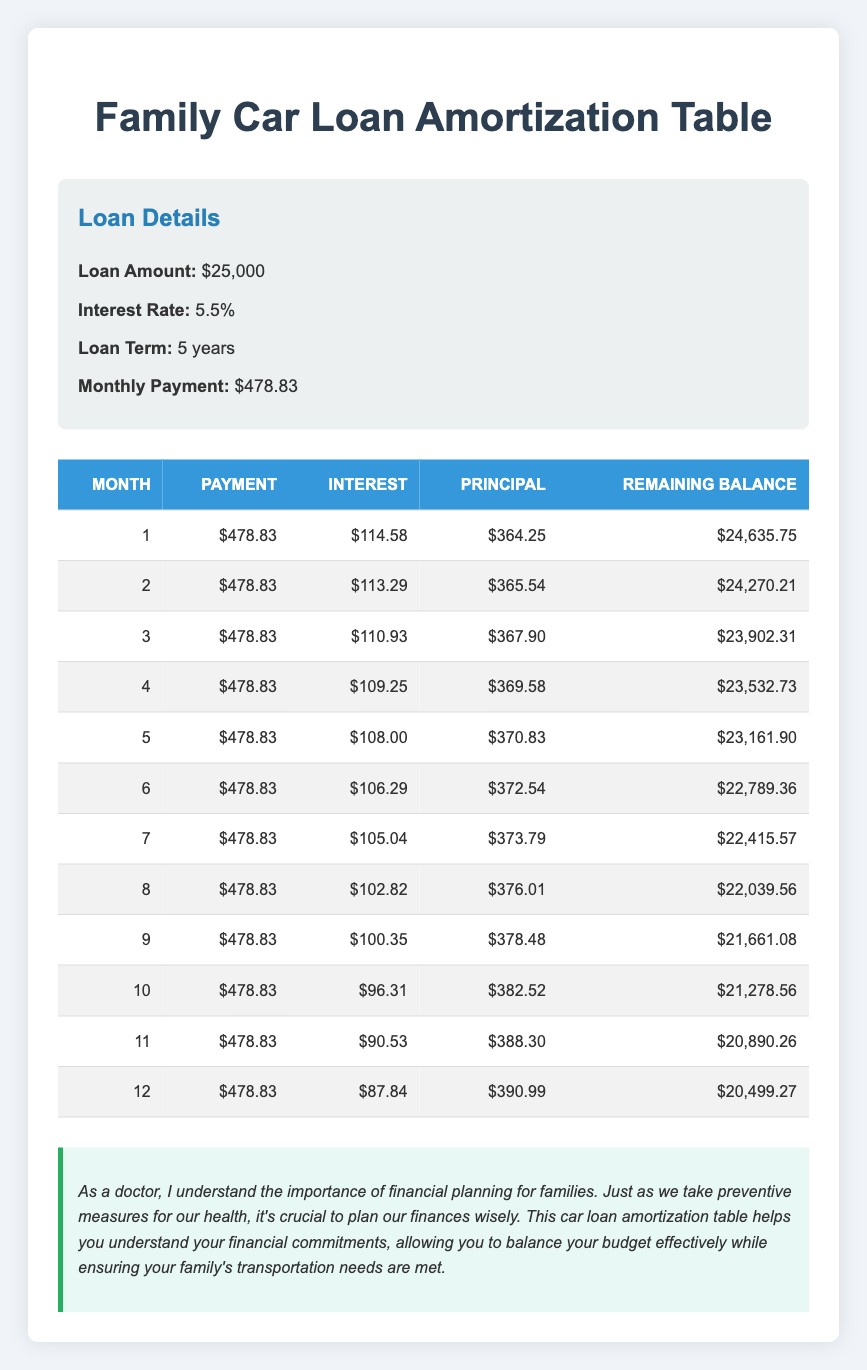What is the monthly payment for the car loan? The monthly payment is explicitly stated in the loan details section of the table. It is $478.83.
Answer: 478.83 What is the interest amount for the first month? The interest amount in the first month is clearly provided in the table, which states it is $114.58.
Answer: 114.58 How much principal is paid off in the second month? The principal payment in the second month is listed in the table as $365.54.
Answer: 365.54 What is the remaining balance after the third month? Referring to the table, the remaining balance after the third month is $23,902.31.
Answer: 23902.31 Is the interest payment higher in the second month than in the first month? In the second month, the interest payment was $113.29, and in the first month, it was $114.58. Since $113.29 is less than $114.58, the statement is false.
Answer: No What is the total amount of interest paid over the first three months? We add the interest amounts for the first three months: $114.58 + $113.29 + $110.93 = $338.80. Therefore, the total amount of interest paid over the first three months is $338.80.
Answer: 338.80 What is the difference between the principal paid in the first month and the principal paid in the fourth month? The principal paid in the first month is $364.25, and in the fourth month, it is $369.58. The difference is calculated as $369.58 - $364.25 = $5.33.
Answer: 5.33 What would be the total remaining balance after the sixth month if no payments were made? The sixth month remaining balance of $22,789.36 is recorded in the table. If no further payments were made, this remaining balance would remain unchanged at $22,789.36.
Answer: 22789.36 In what month is the principal repayment the highest, and what is the amount? By reviewing the principal repayment amounts in the table, the highest principal repayment occurs in the twelfth month, which is $390.99.
Answer: 390.99 